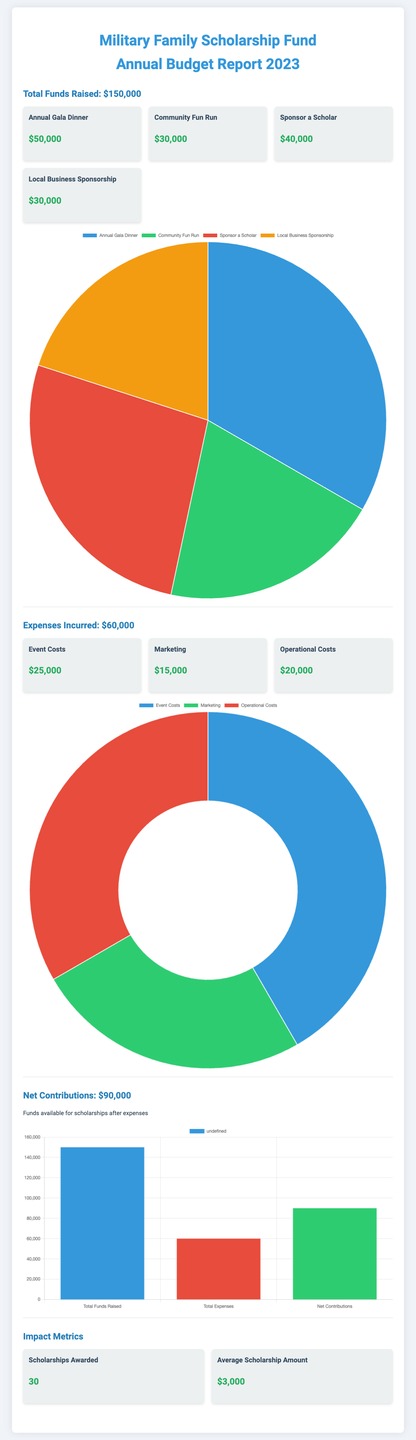What is the total funds raised? The total funds raised is indicated at the beginning of the document, which totals to $150,000.
Answer: $150,000 What is the total expenses incurred? The total expenses incurred is specifically mentioned in the document as $60,000.
Answer: $60,000 What is the net contributions amount? The net contributions are calculated as total funds raised minus expenses incurred, stated as $90,000 in the document.
Answer: $90,000 How much was raised from the Annual Gala Dinner? The document specifies that the Annual Gala Dinner raised $50,000.
Answer: $50,000 What is the average scholarship amount awarded? The document states the average scholarship amount awarded is $3,000.
Answer: $3,000 Which expense category had the highest cost? The expense with the highest cost is Event Costs, totaling $25,000.
Answer: Event Costs How many scholarships were awarded? The document mentions that there were 30 scholarships awarded.
Answer: 30 What percentage of the total funds raised was spent on operational costs? Operational costs amounting to $20,000 represent about 13.33% of the total funds raised, which is calculated as (20,000/150,000) x 100.
Answer: 13.33% What event contributed $40,000 to the funds raised? The document indicates that the "Sponsor a Scholar" event contributed $40,000 to the total funds raised.
Answer: Sponsor a Scholar 